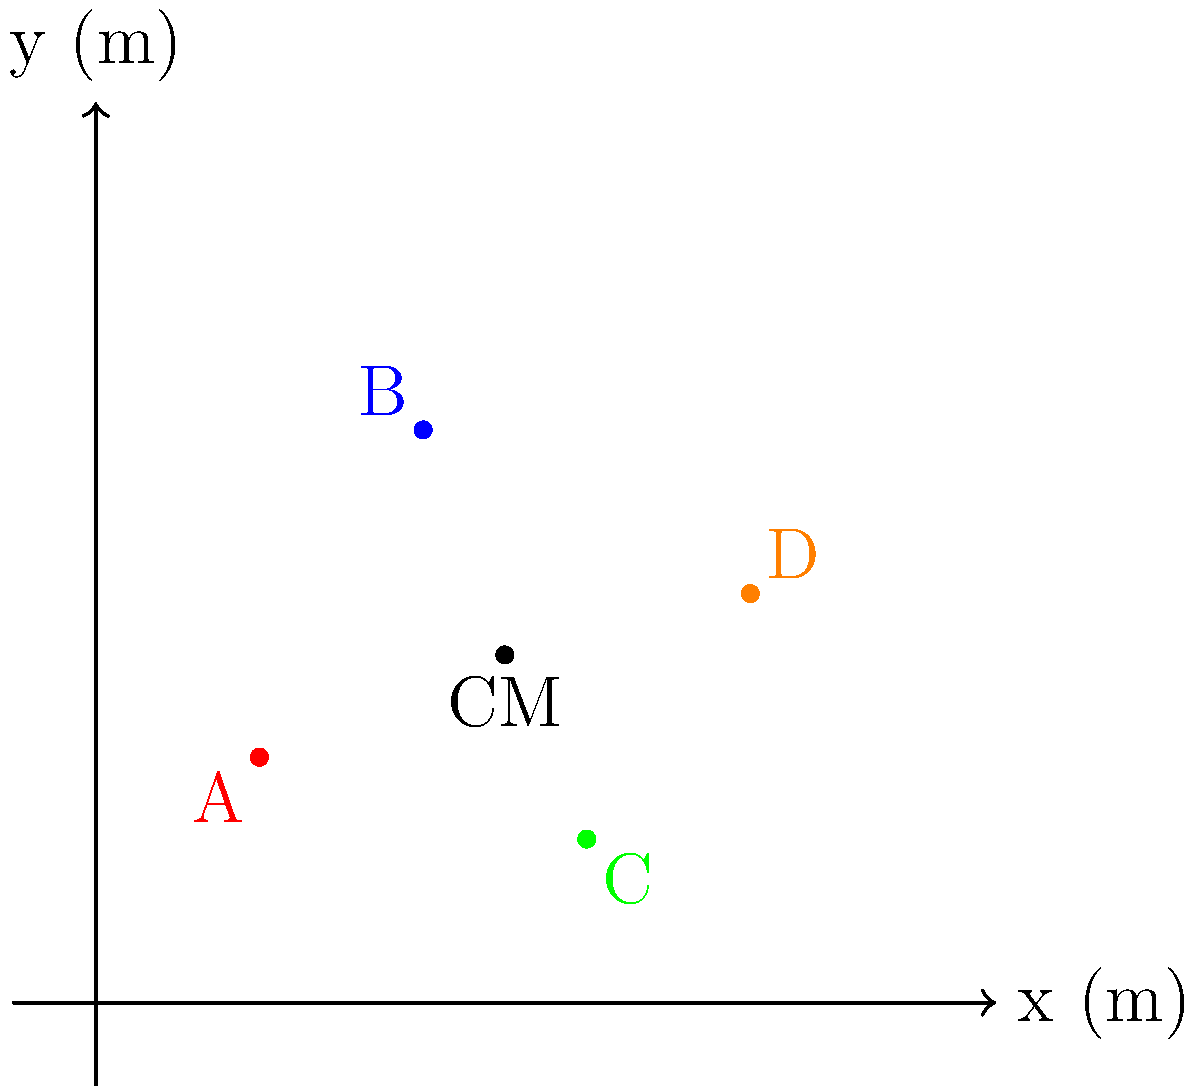A group of four women activists, representing different demographics, are standing together for a photo opportunity during a women's rights campaign. Their positions on a coordinate system are as follows: A(2,3), B(4,7), C(6,2), and D(8,5), where the coordinates are in meters. If all women have equal influence in the organization, where should the photographer position the camera to capture the center of mass of the group? Assume the camera should be aligned with the center of mass in the x-y plane. To find the center of mass of the group, we need to calculate the average x and y coordinates of all the women. Since they have equal influence, we can treat this as a system of particles with equal masses.

Step 1: Calculate the average x-coordinate
$x_{CM} = \frac{x_A + x_B + x_C + x_D}{4}$
$x_{CM} = \frac{2 + 4 + 6 + 8}{4} = \frac{20}{4} = 5$ m

Step 2: Calculate the average y-coordinate
$y_{CM} = \frac{y_A + y_B + y_C + y_D}{4}$
$y_{CM} = \frac{3 + 7 + 2 + 5}{4} = \frac{17}{4} = 4.25$ m

Step 3: The center of mass is located at the point (5, 4.25) in the x-y plane.

This result represents the average position of the group, taking into account their equal influence in the organization. The photographer should position the camera aligned with this point to capture the center of mass of the group, symbolizing their collective strength and unity in the women's rights campaign.
Answer: (5, 4.25) m 